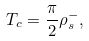Convert formula to latex. <formula><loc_0><loc_0><loc_500><loc_500>T _ { c } = \frac { \pi } { 2 } \rho _ { s } ^ { - } ,</formula> 